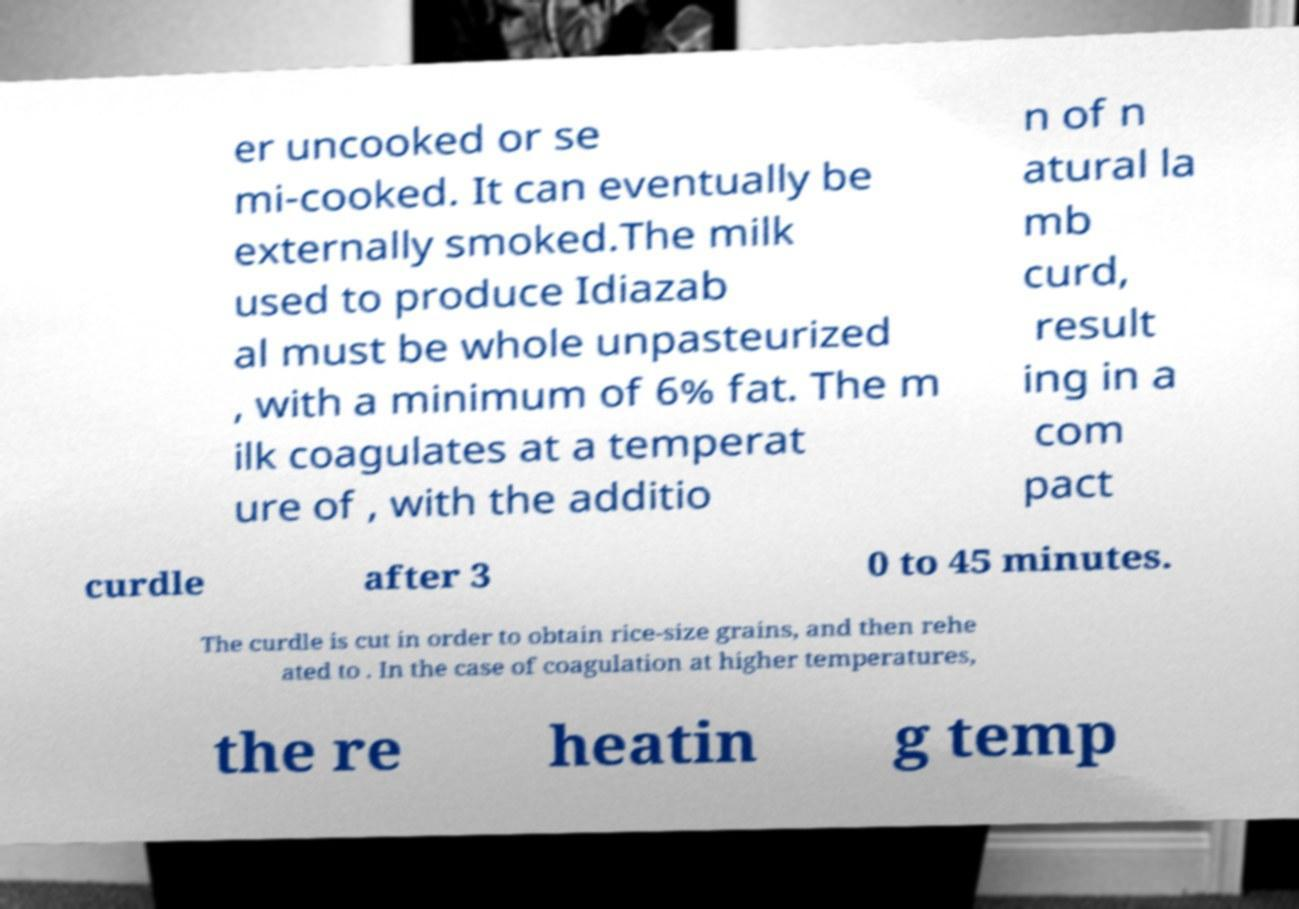What messages or text are displayed in this image? I need them in a readable, typed format. er uncooked or se mi-cooked. It can eventually be externally smoked.The milk used to produce Idiazab al must be whole unpasteurized , with a minimum of 6% fat. The m ilk coagulates at a temperat ure of , with the additio n of n atural la mb curd, result ing in a com pact curdle after 3 0 to 45 minutes. The curdle is cut in order to obtain rice-size grains, and then rehe ated to . In the case of coagulation at higher temperatures, the re heatin g temp 